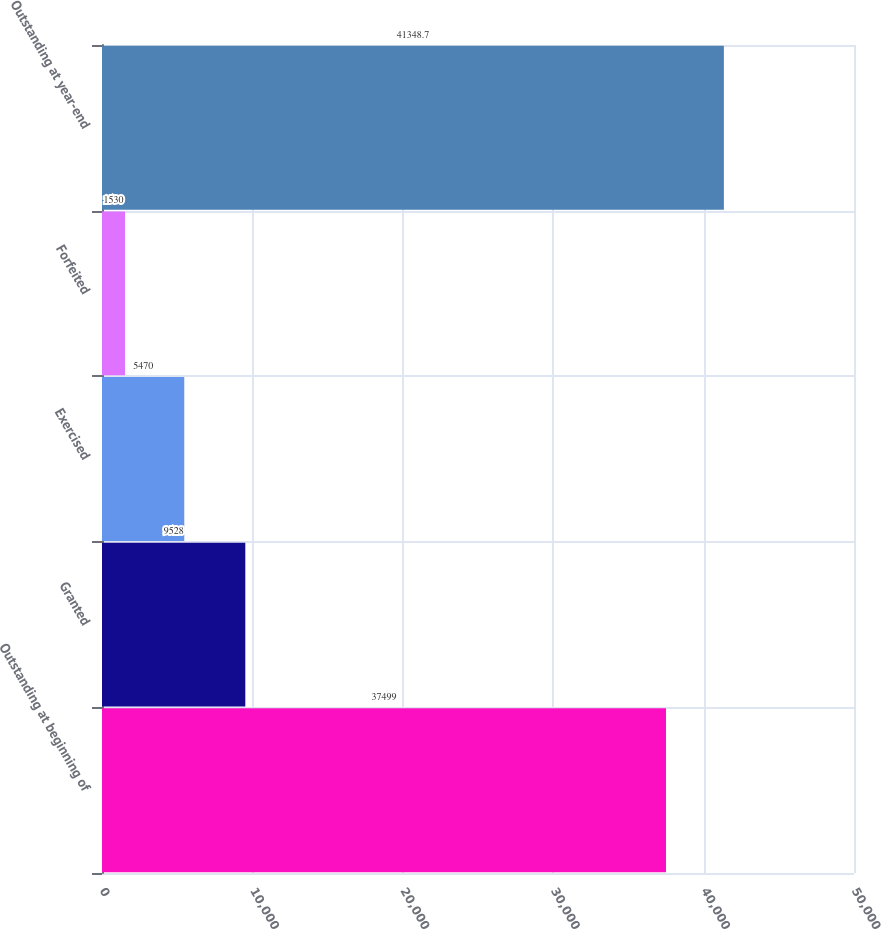<chart> <loc_0><loc_0><loc_500><loc_500><bar_chart><fcel>Outstanding at beginning of<fcel>Granted<fcel>Exercised<fcel>Forfeited<fcel>Outstanding at year-end<nl><fcel>37499<fcel>9528<fcel>5470<fcel>1530<fcel>41348.7<nl></chart> 